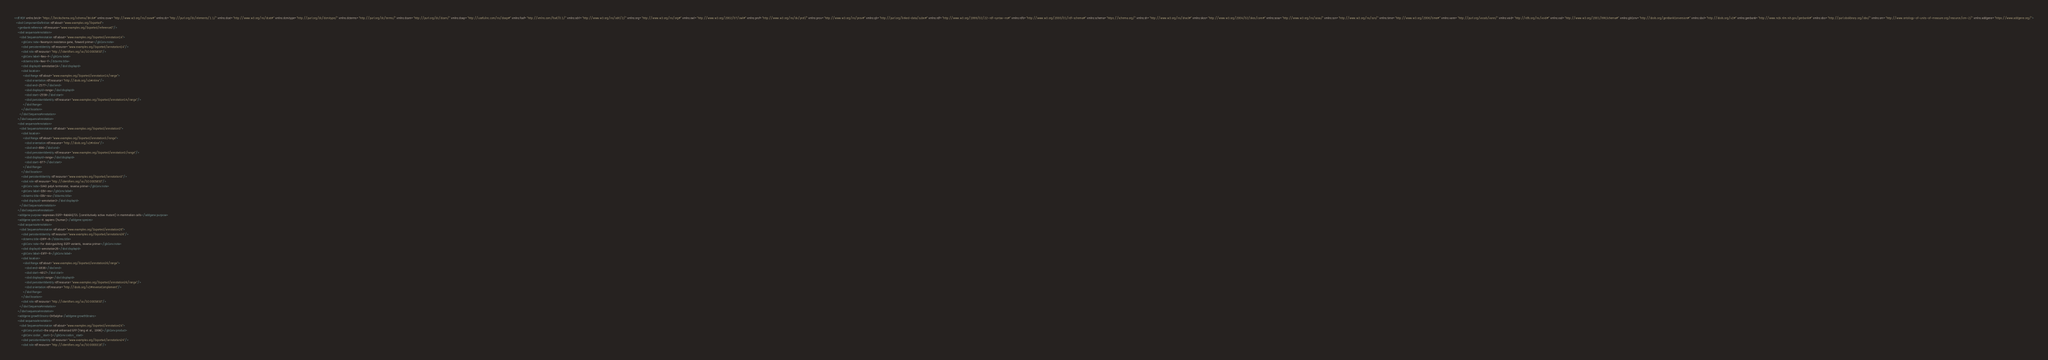<code> <loc_0><loc_0><loc_500><loc_500><_XML_><rdf:RDF xmlns:brick="https://brickschema.org/schema/Brick#" xmlns:csvw="http://www.w3.org/ns/csvw#" xmlns:dc="http://purl.org/dc/elements/1.1/" xmlns:dcat="http://www.w3.org/ns/dcat#" xmlns:dcmitype="http://purl.org/dc/dcmitype/" xmlns:dcterms="http://purl.org/dc/terms/" xmlns:dcam="http://purl.org/dc/dcam/" xmlns:doap="http://usefulinc.com/ns/doap#" xmlns:foaf="http://xmlns.com/foaf/0.1/" xmlns:odrl="http://www.w3.org/ns/odrl/2/" xmlns:org="http://www.w3.org/ns/org#" xmlns:owl="http://www.w3.org/2002/07/owl#" xmlns:prof="http://www.w3.org/ns/dx/prof/" xmlns:prov="http://www.w3.org/ns/prov#" xmlns:qb="http://purl.org/linked-data/cube#" xmlns:rdf="http://www.w3.org/1999/02/22-rdf-syntax-ns#" xmlns:rdfs="http://www.w3.org/2000/01/rdf-schema#" xmlns:schema="https://schema.org/" xmlns:sh="http://www.w3.org/ns/shacl#" xmlns:skos="http://www.w3.org/2004/02/skos/core#" xmlns:sosa="http://www.w3.org/ns/sosa/" xmlns:ssn="http://www.w3.org/ns/ssn/" xmlns:time="http://www.w3.org/2006/time#" xmlns:vann="http://purl.org/vocab/vann/" xmlns:void="http://rdfs.org/ns/void#" xmlns:xsd="http://www.w3.org/2001/XMLSchema#" xmlns:gbConv="http://sbols.org/genBankConversion#" xmlns:sbol="http://sbols.org/v2#" xmlns:genbank="http://www.ncbi.nlm.nih.gov/genbank#" xmlns:obo="http://purl.obolibrary.org/obo/" xmlns:om="http://www.ontology-of-units-of-measure.org/resource/om-2/" xmlns:addgene="https://www.addgene.org/">
  <sbol:ComponentDefinition rdf:about="www.examples.org/Exported">
    <genbank:reference rdf:resource="www.examples.org/Exported/reference0"/>
    <sbol:sequenceAnnotation>
      <sbol:SequenceAnnotation rdf:about="www.examples.org/Exported/annotation14">
        <gbConv:note>Neomycin resistance gene, forward primer</gbConv:note>
        <sbol:persistentIdentity rdf:resource="www.examples.org/Exported/annotation14"/>
        <sbol:role rdf:resource="http://identifiers.org/so/SO:0005850"/>
        <gbConv:label>Neo-F</gbConv:label>
        <dcterms:title>Neo-F</dcterms:title>
        <sbol:displayId>annotation14</sbol:displayId>
        <sbol:location>
          <sbol:Range rdf:about="www.examples.org/Exported/annotation14/range">
            <sbol:orientation rdf:resource="http://sbols.org/v2#inline"/>
            <sbol:end>2577</sbol:end>
            <sbol:displayId>range</sbol:displayId>
            <sbol:start>2558</sbol:start>
            <sbol:persistentIdentity rdf:resource="www.examples.org/Exported/annotation14/range"/>
          </sbol:Range>
        </sbol:location>
      </sbol:SequenceAnnotation>
    </sbol:sequenceAnnotation>
    <sbol:sequenceAnnotation>
      <sbol:SequenceAnnotation rdf:about="www.examples.org/Exported/annotation3">
        <sbol:location>
          <sbol:Range rdf:about="www.examples.org/Exported/annotation3/range">
            <sbol:orientation rdf:resource="http://sbols.org/v2#inline"/>
            <sbol:end>896</sbol:end>
            <sbol:persistentIdentity rdf:resource="www.examples.org/Exported/annotation3/range"/>
            <sbol:displayId>range</sbol:displayId>
            <sbol:start>877</sbol:start>
          </sbol:Range>
        </sbol:location>
        <sbol:persistentIdentity rdf:resource="www.examples.org/Exported/annotation3"/>
        <sbol:role rdf:resource="http://identifiers.org/so/SO:0005850"/>
        <gbConv:note>SV40 polyA terminator, reverse primer</gbConv:note>
        <gbConv:label>EBV-rev</gbConv:label>
        <dcterms:title>EBV-rev</dcterms:title>
        <sbol:displayId>annotation3</sbol:displayId>
      </sbol:SequenceAnnotation>
    </sbol:sequenceAnnotation>
    <addgene:purpose>expresses EGFP-Rab6AQ72L (constitutively active mutant) in mammalian cells</addgene:purpose>
    <addgene:species>H. sapiens (human)</addgene:species>
    <sbol:sequenceAnnotation>
      <sbol:SequenceAnnotation rdf:about="www.examples.org/Exported/annotation26">
        <sbol:persistentIdentity rdf:resource="www.examples.org/Exported/annotation26"/>
        <dcterms:title>EXFP-R</dcterms:title>
        <gbConv:note>For distinguishing EGFP variants, reverse primer</gbConv:note>
        <sbol:displayId>annotation26</sbol:displayId>
        <gbConv:label>EXFP-R</gbConv:label>
        <sbol:location>
          <sbol:Range rdf:about="www.examples.org/Exported/annotation26/range">
            <sbol:end>4936</sbol:end>
            <sbol:start>4917</sbol:start>
            <sbol:displayId>range</sbol:displayId>
            <sbol:persistentIdentity rdf:resource="www.examples.org/Exported/annotation26/range"/>
            <sbol:orientation rdf:resource="http://sbols.org/v2#reverseComplement"/>
          </sbol:Range>
        </sbol:location>
        <sbol:role rdf:resource="http://identifiers.org/so/SO:0005850"/>
      </sbol:SequenceAnnotation>
    </sbol:sequenceAnnotation>
    <addgene:growthStrains>DH5alpha</addgene:growthStrains>
    <sbol:sequenceAnnotation>
      <sbol:SequenceAnnotation rdf:about="www.examples.org/Exported/annotation24">
        <gbConv:product>the original enhanced GFP (Yang et al., 1996)</gbConv:product>
        <gbConv:codon_start>1</gbConv:codon_start>
        <sbol:persistentIdentity rdf:resource="www.examples.org/Exported/annotation24"/>
        <sbol:role rdf:resource="http://identifiers.org/so/SO:0000316"/></code> 